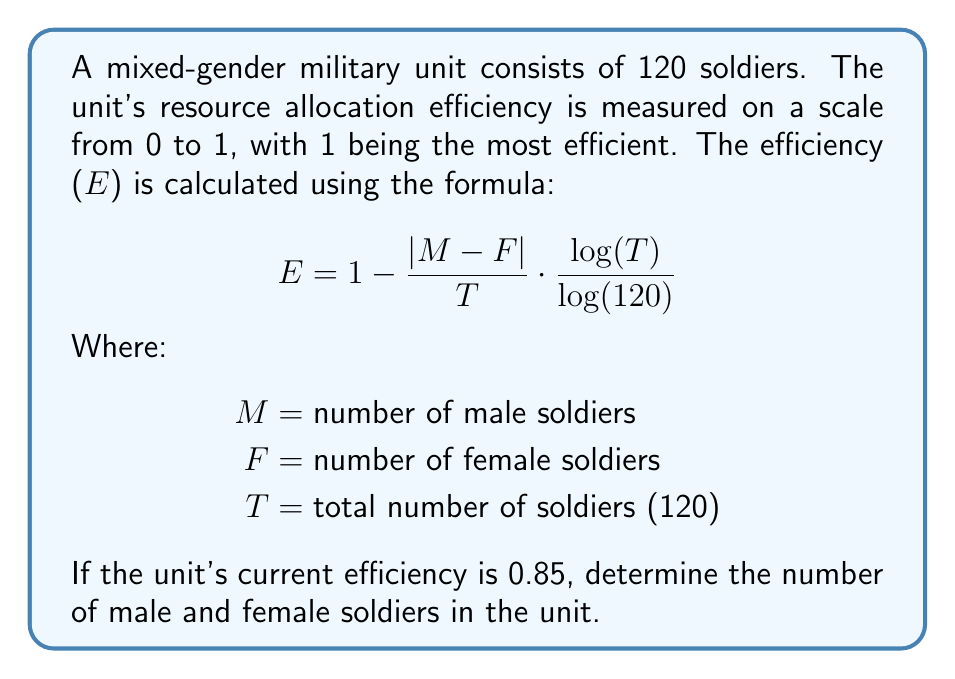Can you solve this math problem? Let's approach this step-by-step:

1) We know that $T = 120$ and $E = 0.85$. Let's substitute these into the formula:

   $$ 0.85 = 1 - \frac{|M - F|}{120} \cdot \frac{\log(120)}{\log(120)} $$

2) Simplify:
   $$ 0.85 = 1 - \frac{|M - F|}{120} $$

3) Subtract both sides from 1:
   $$ 0.15 = \frac{|M - F|}{120} $$

4) Multiply both sides by 120:
   $$ 18 = |M - F| $$

5) This means the difference between the number of male and female soldiers is 18.

6) We know that $M + F = 120$ (total number of soldiers)

7) Let's consider two cases:
   Case 1: $M - F = 18$
   Case 2: $F - M = 18$

8) For Case 1:
   $M - F = 18$ and $M + F = 120$
   Adding these equations: $2M = 138$
   $M = 69$, $F = 51$

9) For Case 2:
   $F - M = 18$ and $M + F = 120$
   Adding these equations: $2F = 138$
   $F = 69$, $M = 51$

Both cases satisfy the conditions, so there are two possible solutions.
Answer: There are two possible solutions:
1) 69 male soldiers and 51 female soldiers
2) 51 male soldiers and 69 female soldiers 